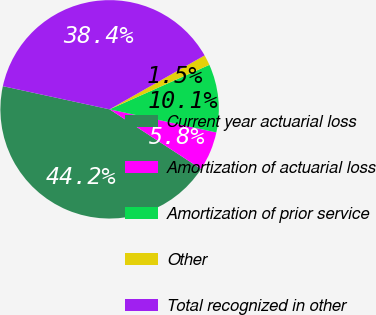Convert chart. <chart><loc_0><loc_0><loc_500><loc_500><pie_chart><fcel>Current year actuarial loss<fcel>Amortization of actuarial loss<fcel>Amortization of prior service<fcel>Other<fcel>Total recognized in other<nl><fcel>44.21%<fcel>5.8%<fcel>10.07%<fcel>1.54%<fcel>38.38%<nl></chart> 